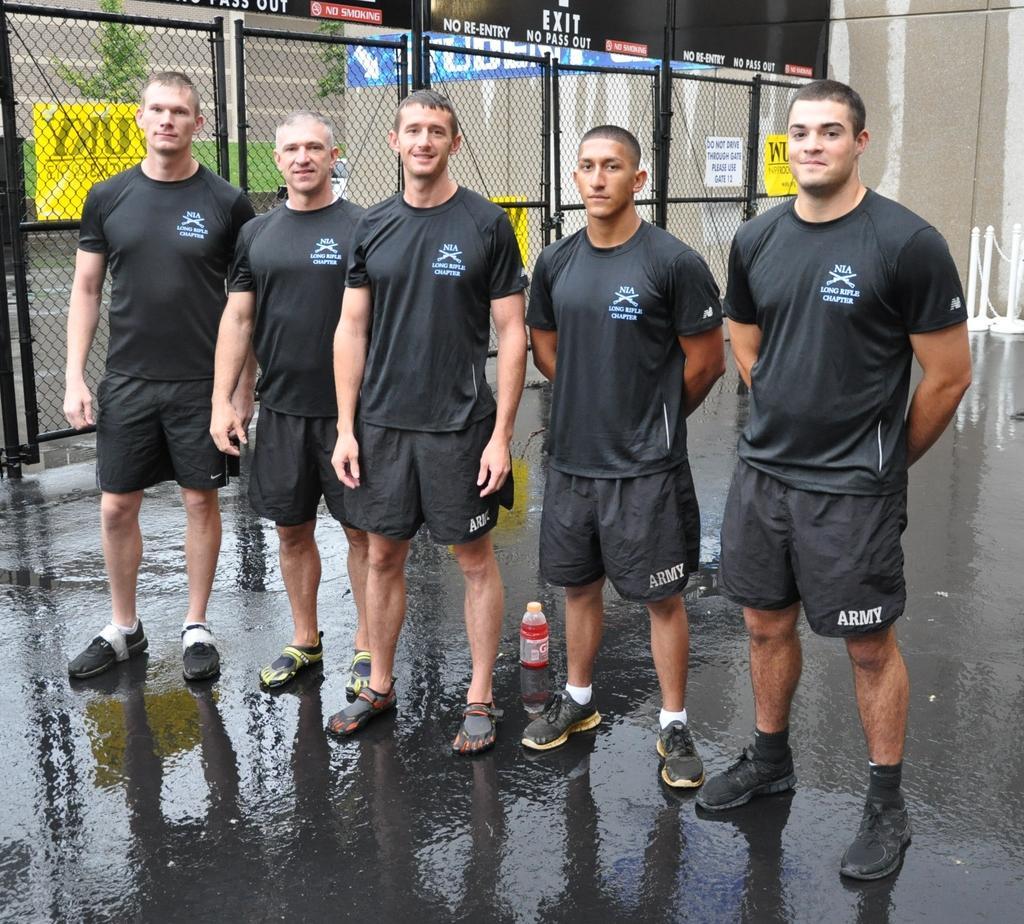How would you summarize this image in a sentence or two? In this image I can see there are five people standing and they are wearing black shirts and trousers. There is a fence, plants, banner and buildings in the backdrop. 